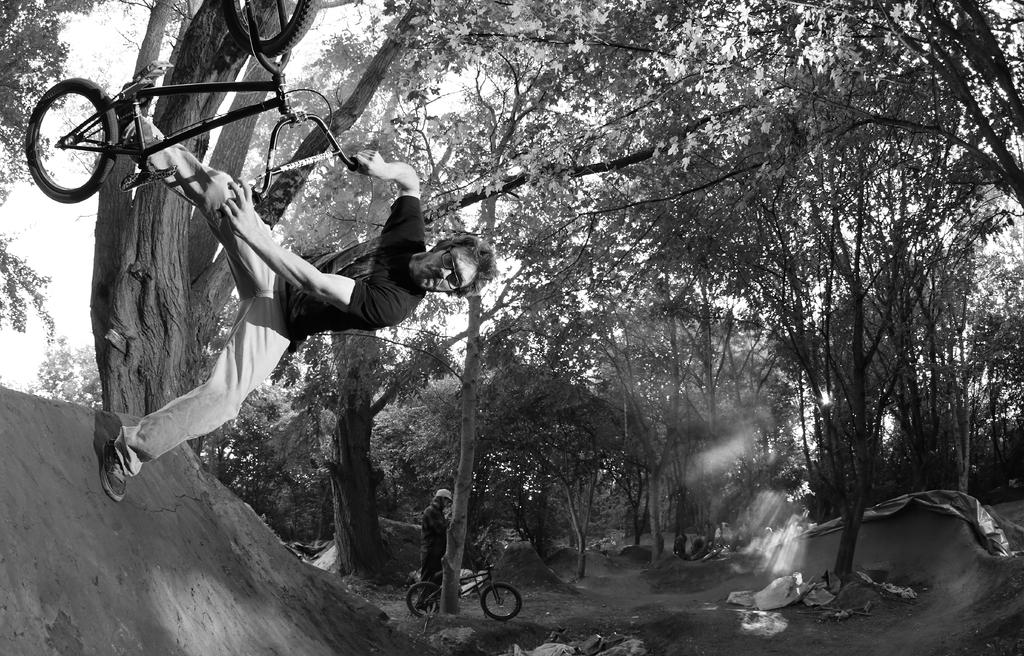What is the main activity being performed in the image? There is a person performing stunts on a bicycle in the image. What can be seen in the background of the image? There are trees visible in the background of the image. Are there any other people in the image? Yes, there are other people with bicycles in the image. What is the rate of fire of the gun in the image? There is no gun present in the image; it features a person performing stunts on a bicycle and other people with bicycles. 